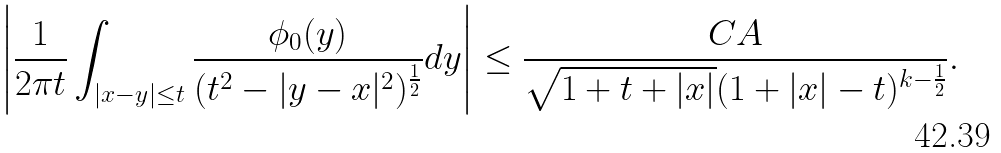Convert formula to latex. <formula><loc_0><loc_0><loc_500><loc_500>\left | \frac { 1 } { 2 \pi t } \int _ { | x - y | \leq t } \frac { \phi _ { 0 } ( y ) } { ( t ^ { 2 } - | y - x | ^ { 2 } ) ^ { \frac { 1 } { 2 } } } d y \right | \leq \frac { C A } { \sqrt { 1 + t + | x | } ( 1 + | x | - t ) ^ { k - \frac { 1 } { 2 } } } .</formula> 